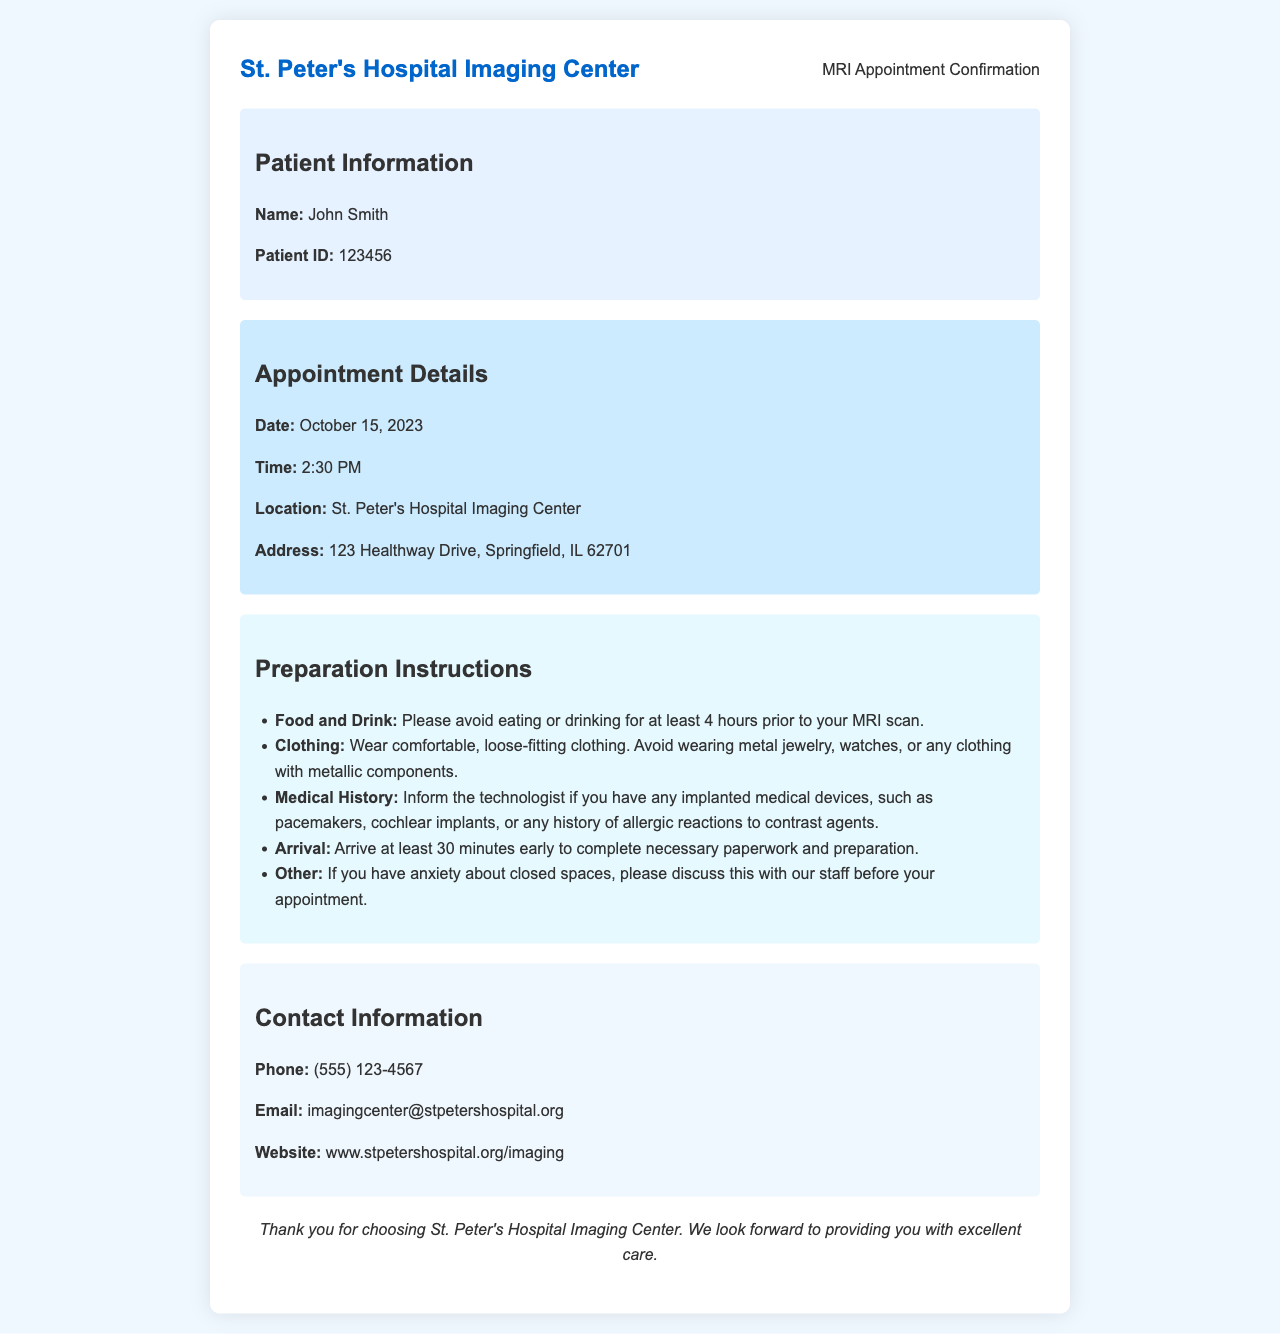What is the patient's name? The patient's name is mentioned in the patient information section of the document.
Answer: John Smith What is the date of the MRI appointment? The date is specified in the appointment details section of the document.
Answer: October 15, 2023 What is the address of the imaging center? The address is provided in the appointment details section of the document.
Answer: 123 Healthway Drive, Springfield, IL 62701 How long should the patient avoid eating or drinking before the scan? This information is included in the preparation instructions section of the document.
Answer: 4 hours What time should the patient arrive for the appointment? The arrival time is indicated in the preparation instructions section.
Answer: 30 minutes early What should the patient wear to the MRI appointment? The clothing guidance is outlined in the preparation instructions section of the document.
Answer: Comfortable, loose-fitting clothing What should the patient inform the technologist about? This detail is provided in the preparation instructions section.
Answer: Implanted medical devices What is the contact phone number for the imaging center? The phone number is listed in the contact information section of the document.
Answer: (555) 123-4567 What type of document is this? The overall content and title suggest the nature of this document.
Answer: Appointment confirmation letter 